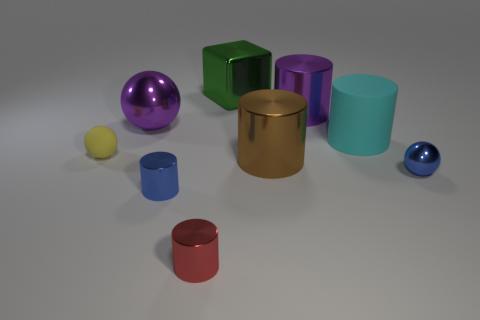There is a rubber object left of the large object that is to the left of the tiny shiny thing to the left of the small red thing; what is its shape?
Give a very brief answer. Sphere. Are there the same number of brown cylinders right of the matte cylinder and shiny balls to the left of the blue sphere?
Your response must be concise. No. What color is the rubber cylinder that is the same size as the purple sphere?
Your response must be concise. Cyan. What number of large objects are either cyan balls or blue things?
Provide a short and direct response. 0. There is a object that is both right of the big purple metal cylinder and in front of the big brown cylinder; what is its material?
Provide a short and direct response. Metal. Do the blue metal object that is on the left side of the blue sphere and the purple metal thing left of the green metallic cube have the same shape?
Make the answer very short. No. There is a big metallic object that is the same color as the big metal ball; what shape is it?
Offer a terse response. Cylinder. What number of things are either rubber things that are to the right of the brown cylinder or balls?
Offer a very short reply. 4. Does the cyan matte thing have the same size as the blue shiny sphere?
Keep it short and to the point. No. What color is the large thing that is left of the small red cylinder?
Offer a very short reply. Purple. 